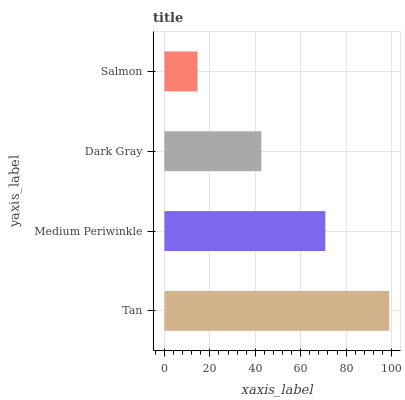Is Salmon the minimum?
Answer yes or no. Yes. Is Tan the maximum?
Answer yes or no. Yes. Is Medium Periwinkle the minimum?
Answer yes or no. No. Is Medium Periwinkle the maximum?
Answer yes or no. No. Is Tan greater than Medium Periwinkle?
Answer yes or no. Yes. Is Medium Periwinkle less than Tan?
Answer yes or no. Yes. Is Medium Periwinkle greater than Tan?
Answer yes or no. No. Is Tan less than Medium Periwinkle?
Answer yes or no. No. Is Medium Periwinkle the high median?
Answer yes or no. Yes. Is Dark Gray the low median?
Answer yes or no. Yes. Is Salmon the high median?
Answer yes or no. No. Is Tan the low median?
Answer yes or no. No. 